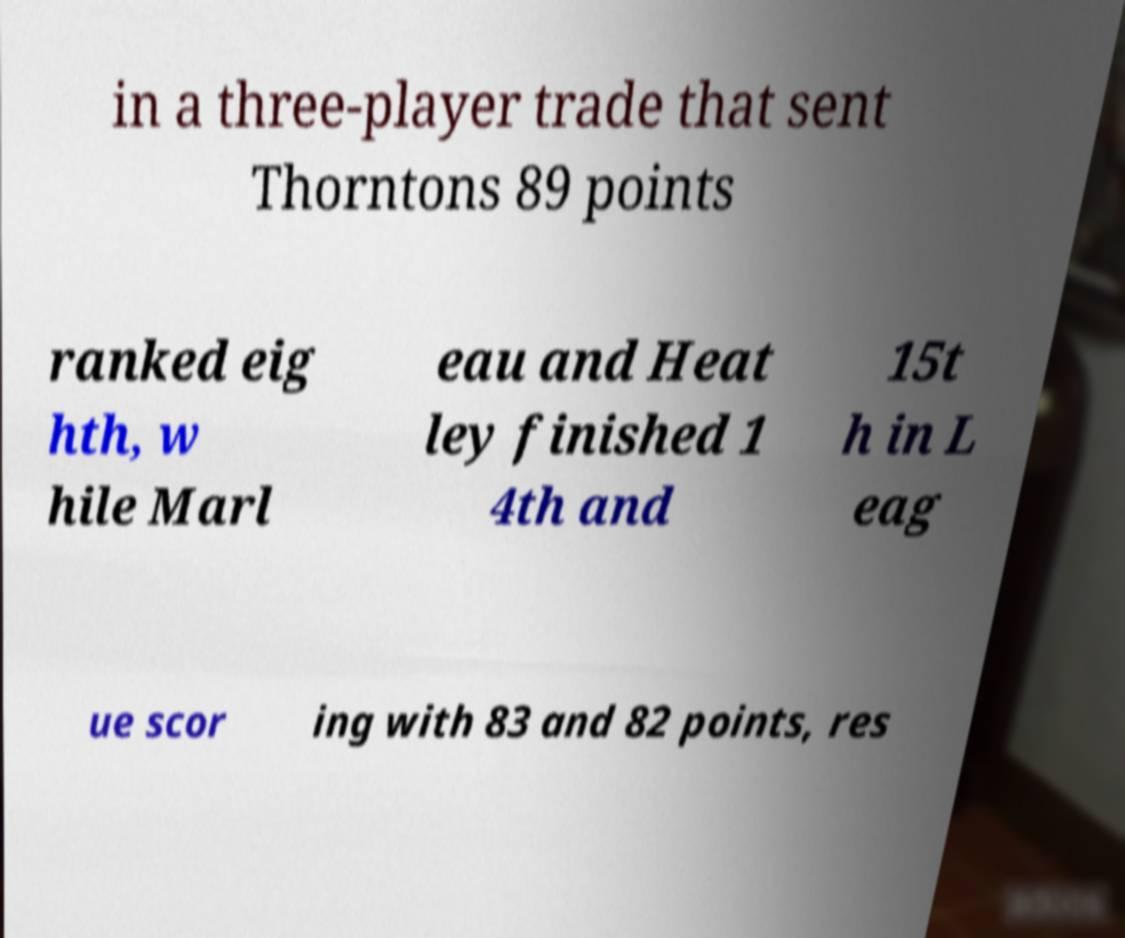Can you read and provide the text displayed in the image?This photo seems to have some interesting text. Can you extract and type it out for me? in a three-player trade that sent Thorntons 89 points ranked eig hth, w hile Marl eau and Heat ley finished 1 4th and 15t h in L eag ue scor ing with 83 and 82 points, res 